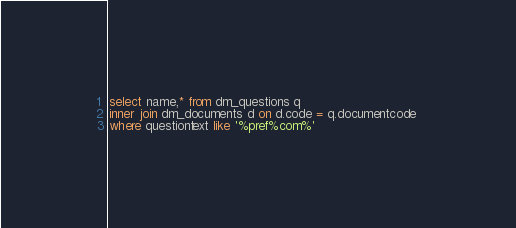<code> <loc_0><loc_0><loc_500><loc_500><_SQL_>
select name,* from dm_questions q  
inner join dm_documents d on d.code = q.documentcode 
where questiontext like '%pref%com%' 





</code> 